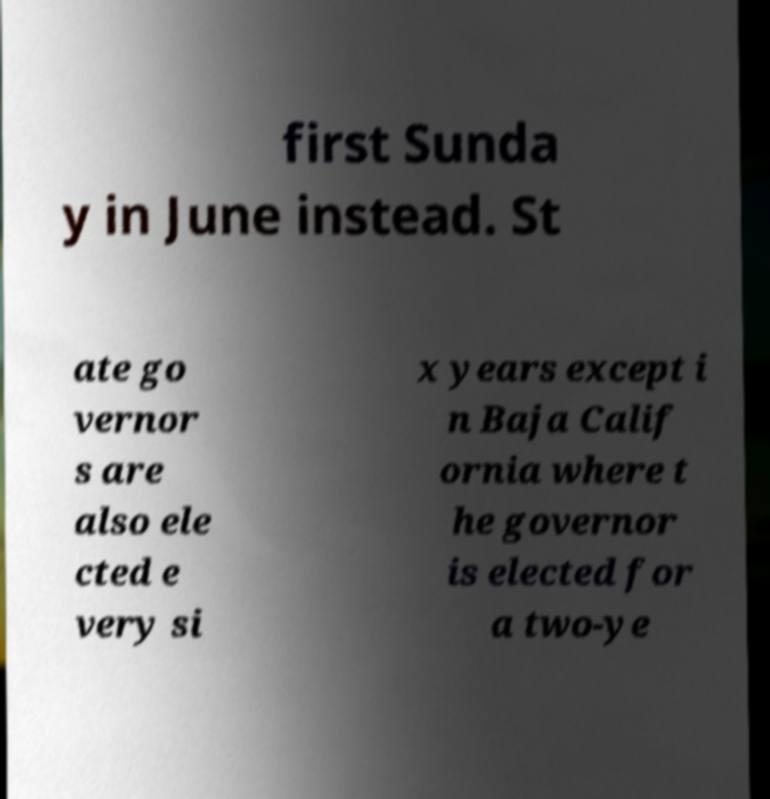There's text embedded in this image that I need extracted. Can you transcribe it verbatim? first Sunda y in June instead. St ate go vernor s are also ele cted e very si x years except i n Baja Calif ornia where t he governor is elected for a two-ye 